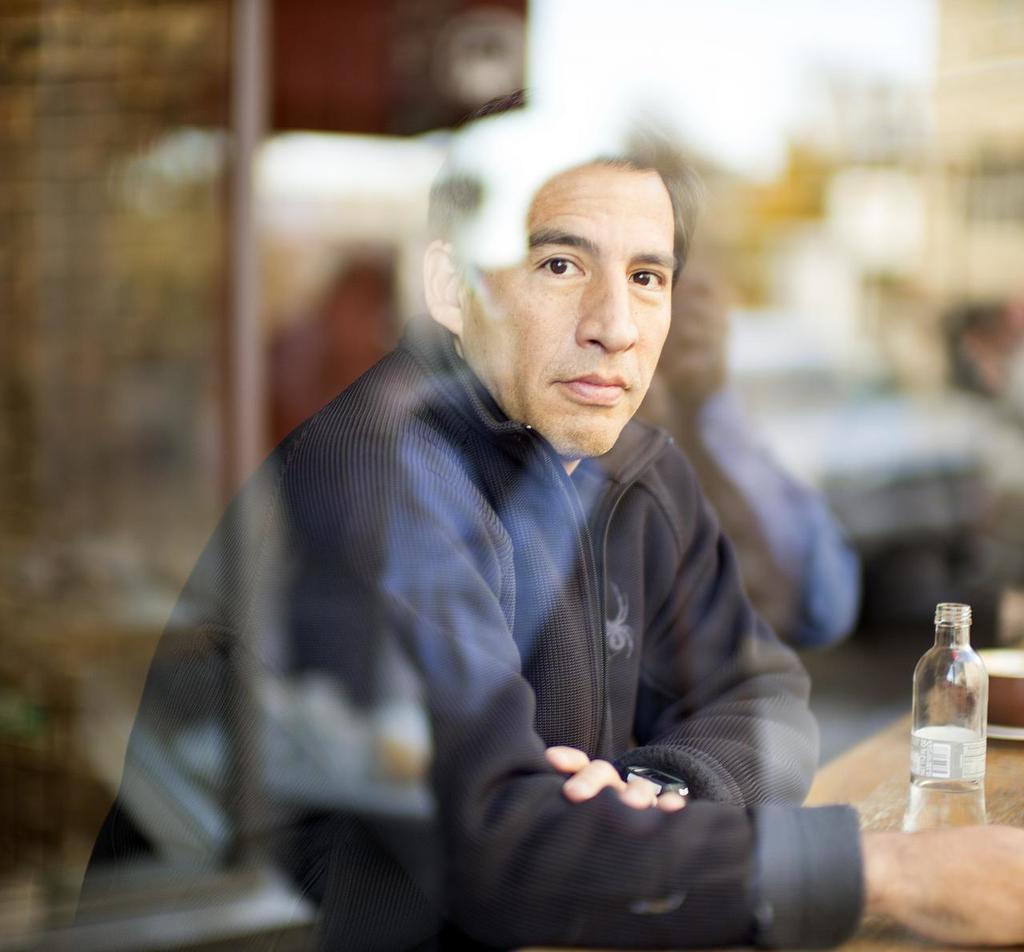Can you describe this image briefly? In this picture, man in black jacket is sitting in front of table on which water bottle and bowl are placed and behind him, it is blurred. 